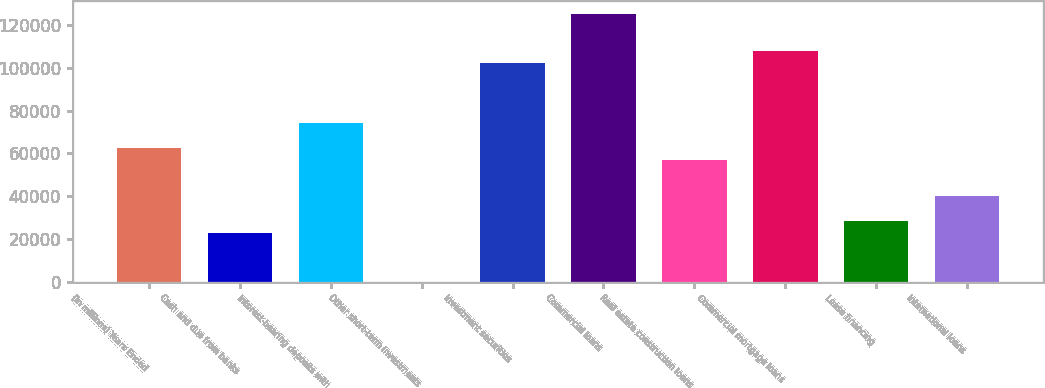Convert chart. <chart><loc_0><loc_0><loc_500><loc_500><bar_chart><fcel>(in millions) Years Ended<fcel>Cash and due from banks<fcel>Interest-bearing deposits with<fcel>Other short-term investments<fcel>Investment securities<fcel>Commercial loans<fcel>Real estate construction loans<fcel>Commercial mortgage loans<fcel>Lease financing<fcel>International loans<nl><fcel>62592.5<fcel>22843<fcel>73949.5<fcel>129<fcel>102342<fcel>125056<fcel>56914<fcel>108020<fcel>28521.5<fcel>39878.5<nl></chart> 